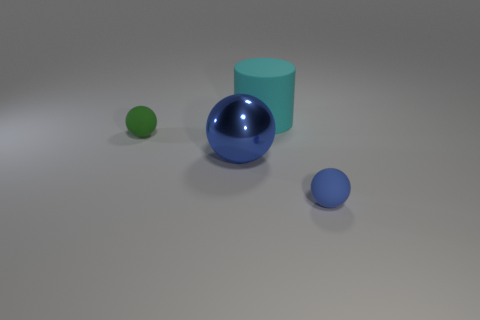There is another object that is the same color as the big shiny thing; what is its size?
Provide a succinct answer. Small. What shape is the small rubber thing that is the same color as the large sphere?
Your answer should be very brief. Sphere. There is a rubber object in front of the large ball; does it have the same color as the big ball?
Make the answer very short. Yes. What color is the large ball?
Ensure brevity in your answer.  Blue. There is a tiny thing on the right side of the small green sphere; are there any cyan matte cylinders that are in front of it?
Give a very brief answer. No. There is a rubber object that is in front of the tiny ball that is behind the tiny blue ball; what shape is it?
Your answer should be very brief. Sphere. Is the number of matte objects less than the number of shiny cylinders?
Keep it short and to the point. No. Do the big sphere and the tiny green ball have the same material?
Offer a terse response. No. What color is the thing that is behind the metallic thing and left of the big cyan matte thing?
Provide a short and direct response. Green. Is there another thing of the same size as the cyan thing?
Provide a succinct answer. Yes. 